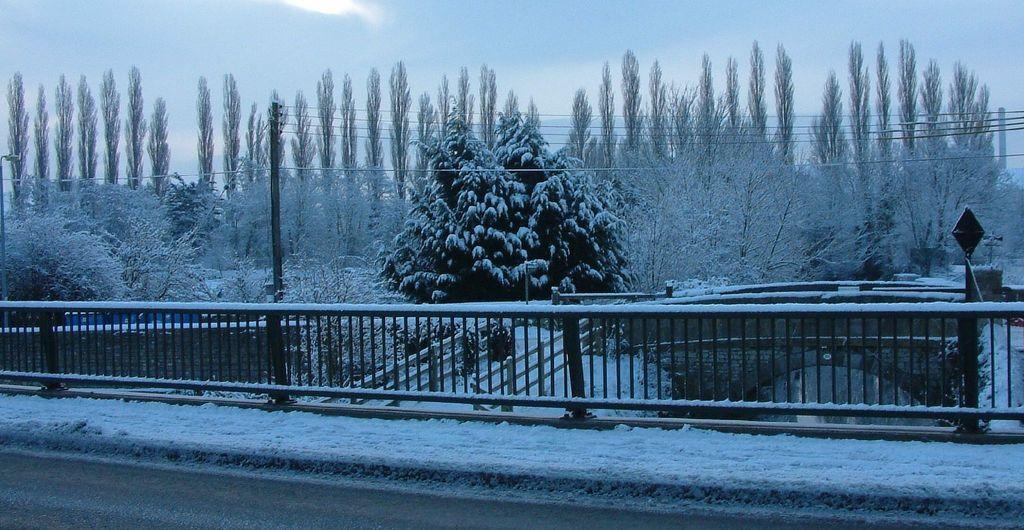How would you summarize this image in a sentence or two? In this image I can see few trees, snow, current poles, wires, sky, fencing, few objects and the board. 